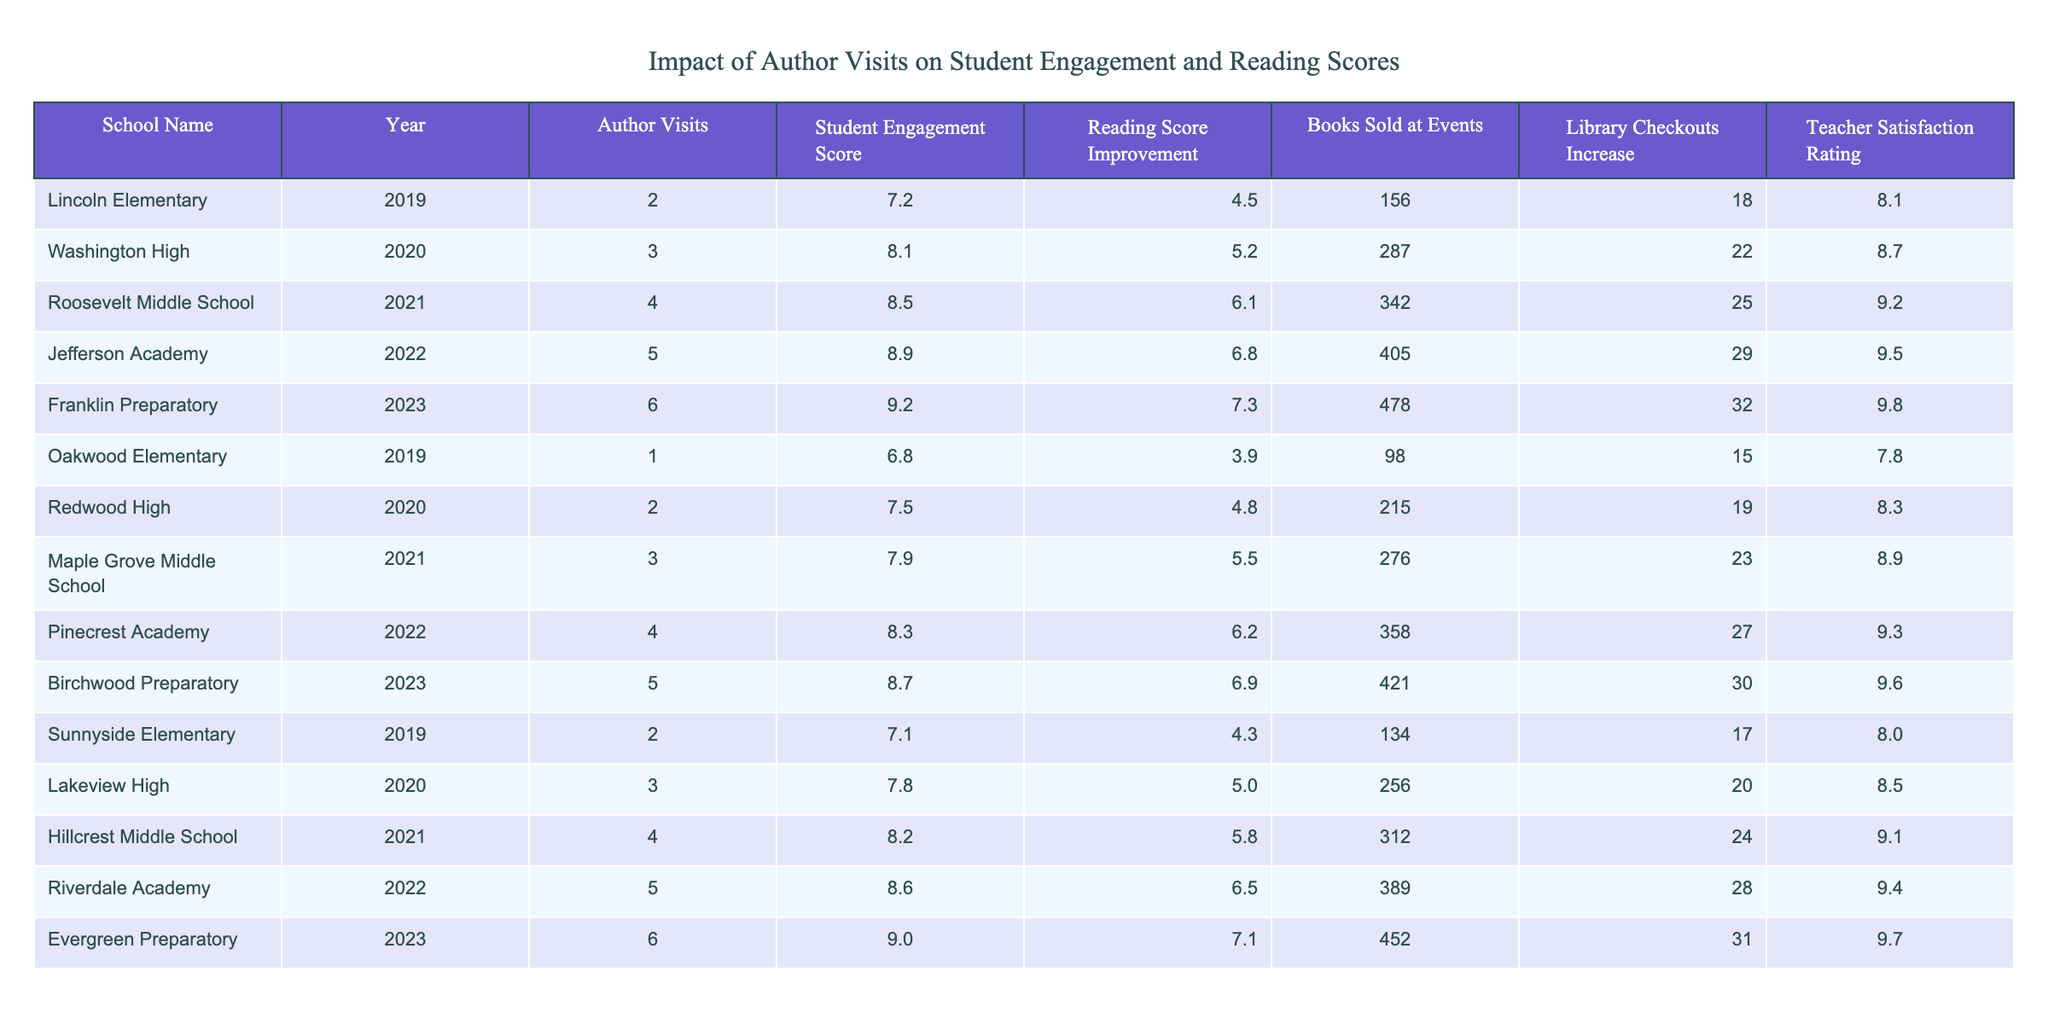What was the highest Student Engagement Score recorded? The highest Student Engagement Score in the table is 9.2, recorded at Franklin Preparatory in 2023.
Answer: 9.2 Which school had the most Author Visits? Franklin Preparatory in 2023 had the most Author Visits with a total of 6.
Answer: 6 What is the average Reading Score Improvement across all years? The total Reading Score Improvement percentages are (4.5 + 5.2 + 6.1 + 6.8 + 7.3 + 3.9 + 4.8 + 5.5 + 6.2 + 6.9 + 4.3 + 5.0 + 5.8 + 6.5 + 7.1) = 82.9. There are 15 data points, therefore the average is 82.9/15 = 5.53%.
Answer: 5.53% Did all schools increase Library Checkouts after Author Visits? Upon reviewing the data, all schools listed show an increase in Library Checkouts, indicating a positive impact from Author Visits.
Answer: Yes Which school demonstrated the most significant improvement in Student Engagement Score from 2019 to 2023? From 2019 to 2023, Franklin Preparatory saw an increase from 7.2 to 9.2, which is a difference of 2.0, making it the school with the most significant improvement in Student Engagement Score.
Answer: Franklin Preparatory What was the trend in Teacher Satisfaction Rating over the years? By examining the data, Teacher Satisfaction Rating increased from 7.8 in 2019 to 9.8 in 2023, indicating a positive trend over the years.
Answer: Increased Which year had the highest number of Books Sold at Events? In 2023, Franklin Preparatory had the highest number of Books Sold at Events, a total of 478.
Answer: 478 Which school in 2021 had the lowest Reading Score Improvement? Maple Grove Middle School in 2021 had the lowest Reading Score Improvement at 5.5%.
Answer: 5.5% What is the difference in Teacher Satisfaction Rating between Jefferson Academy and Oakwood Elementary? Jefferson Academy has a Teacher Satisfaction Rating of 9.5 and Oakwood Elementary has 7.8, so the difference is 9.5 - 7.8 = 1.7.
Answer: 1.7 What overall trend can be observed in Student Engagement Scores from 2019 to 2023? The Student Engagement Scores have consistently increased each year from 7.2 in 2019 to 9.2 in 2023, indicating a positive trend.
Answer: Increased Which schools had a Library Checkouts Increase higher than 30%? Only Franklin Preparatory and Evergreen Preparatory had Library Checkouts Increases of 32% and 31%, respectively, making them the only schools exceeding 30%.
Answer: Franklin Preparatory, Evergreen Preparatory 